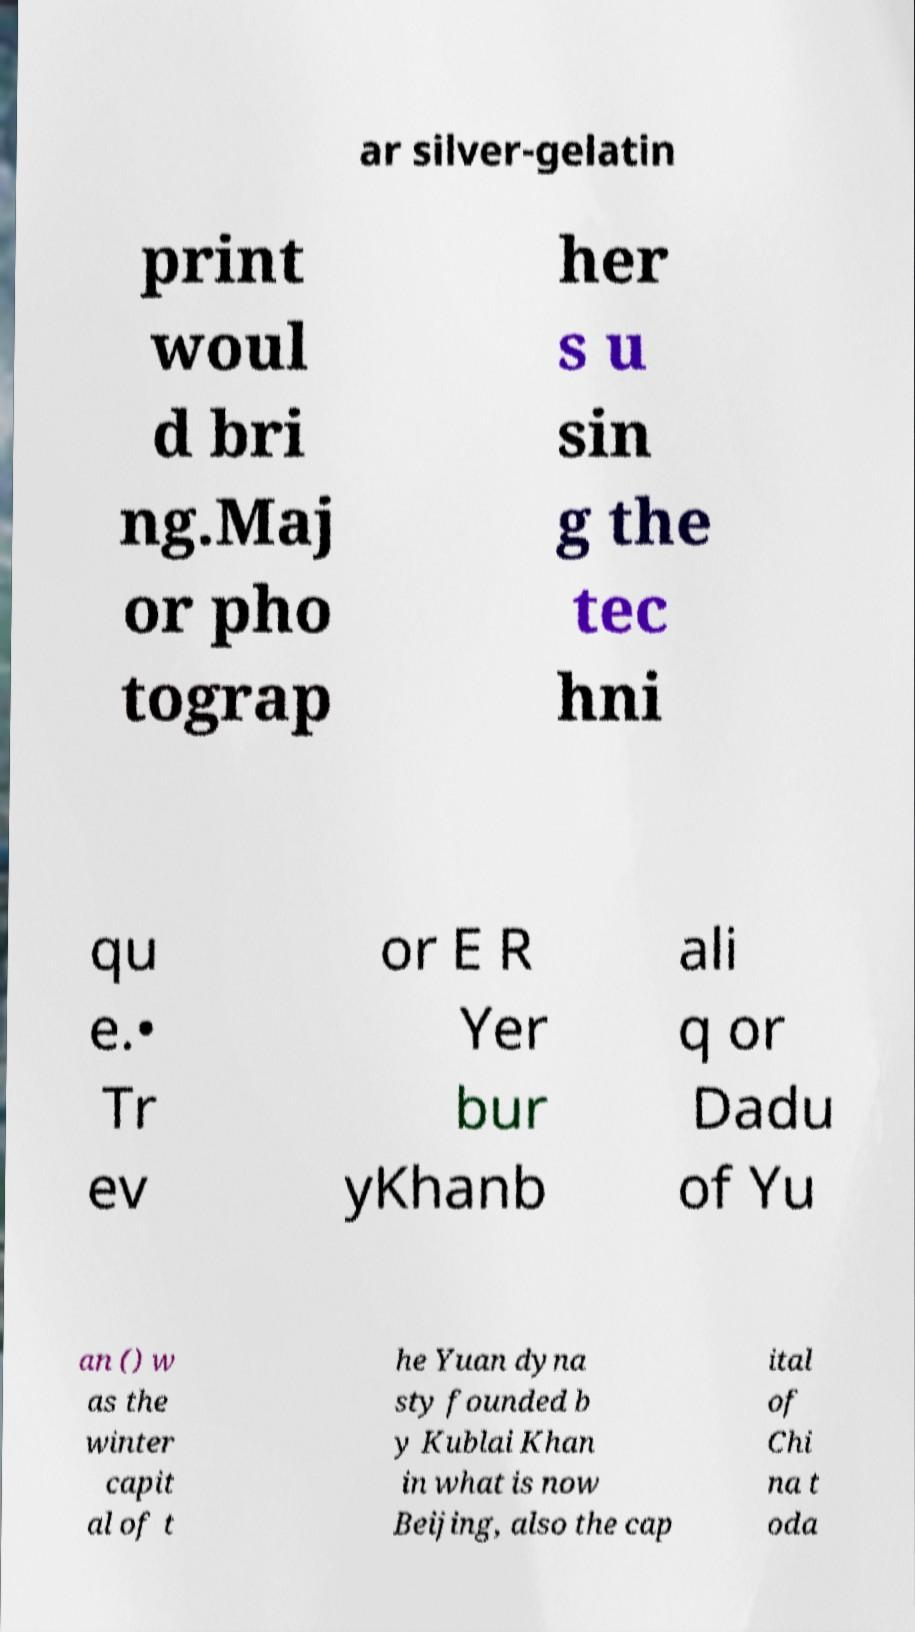Please read and relay the text visible in this image. What does it say? ar silver-gelatin print woul d bri ng.Maj or pho tograp her s u sin g the tec hni qu e.• Tr ev or E R Yer bur yKhanb ali q or Dadu of Yu an () w as the winter capit al of t he Yuan dyna sty founded b y Kublai Khan in what is now Beijing, also the cap ital of Chi na t oda 